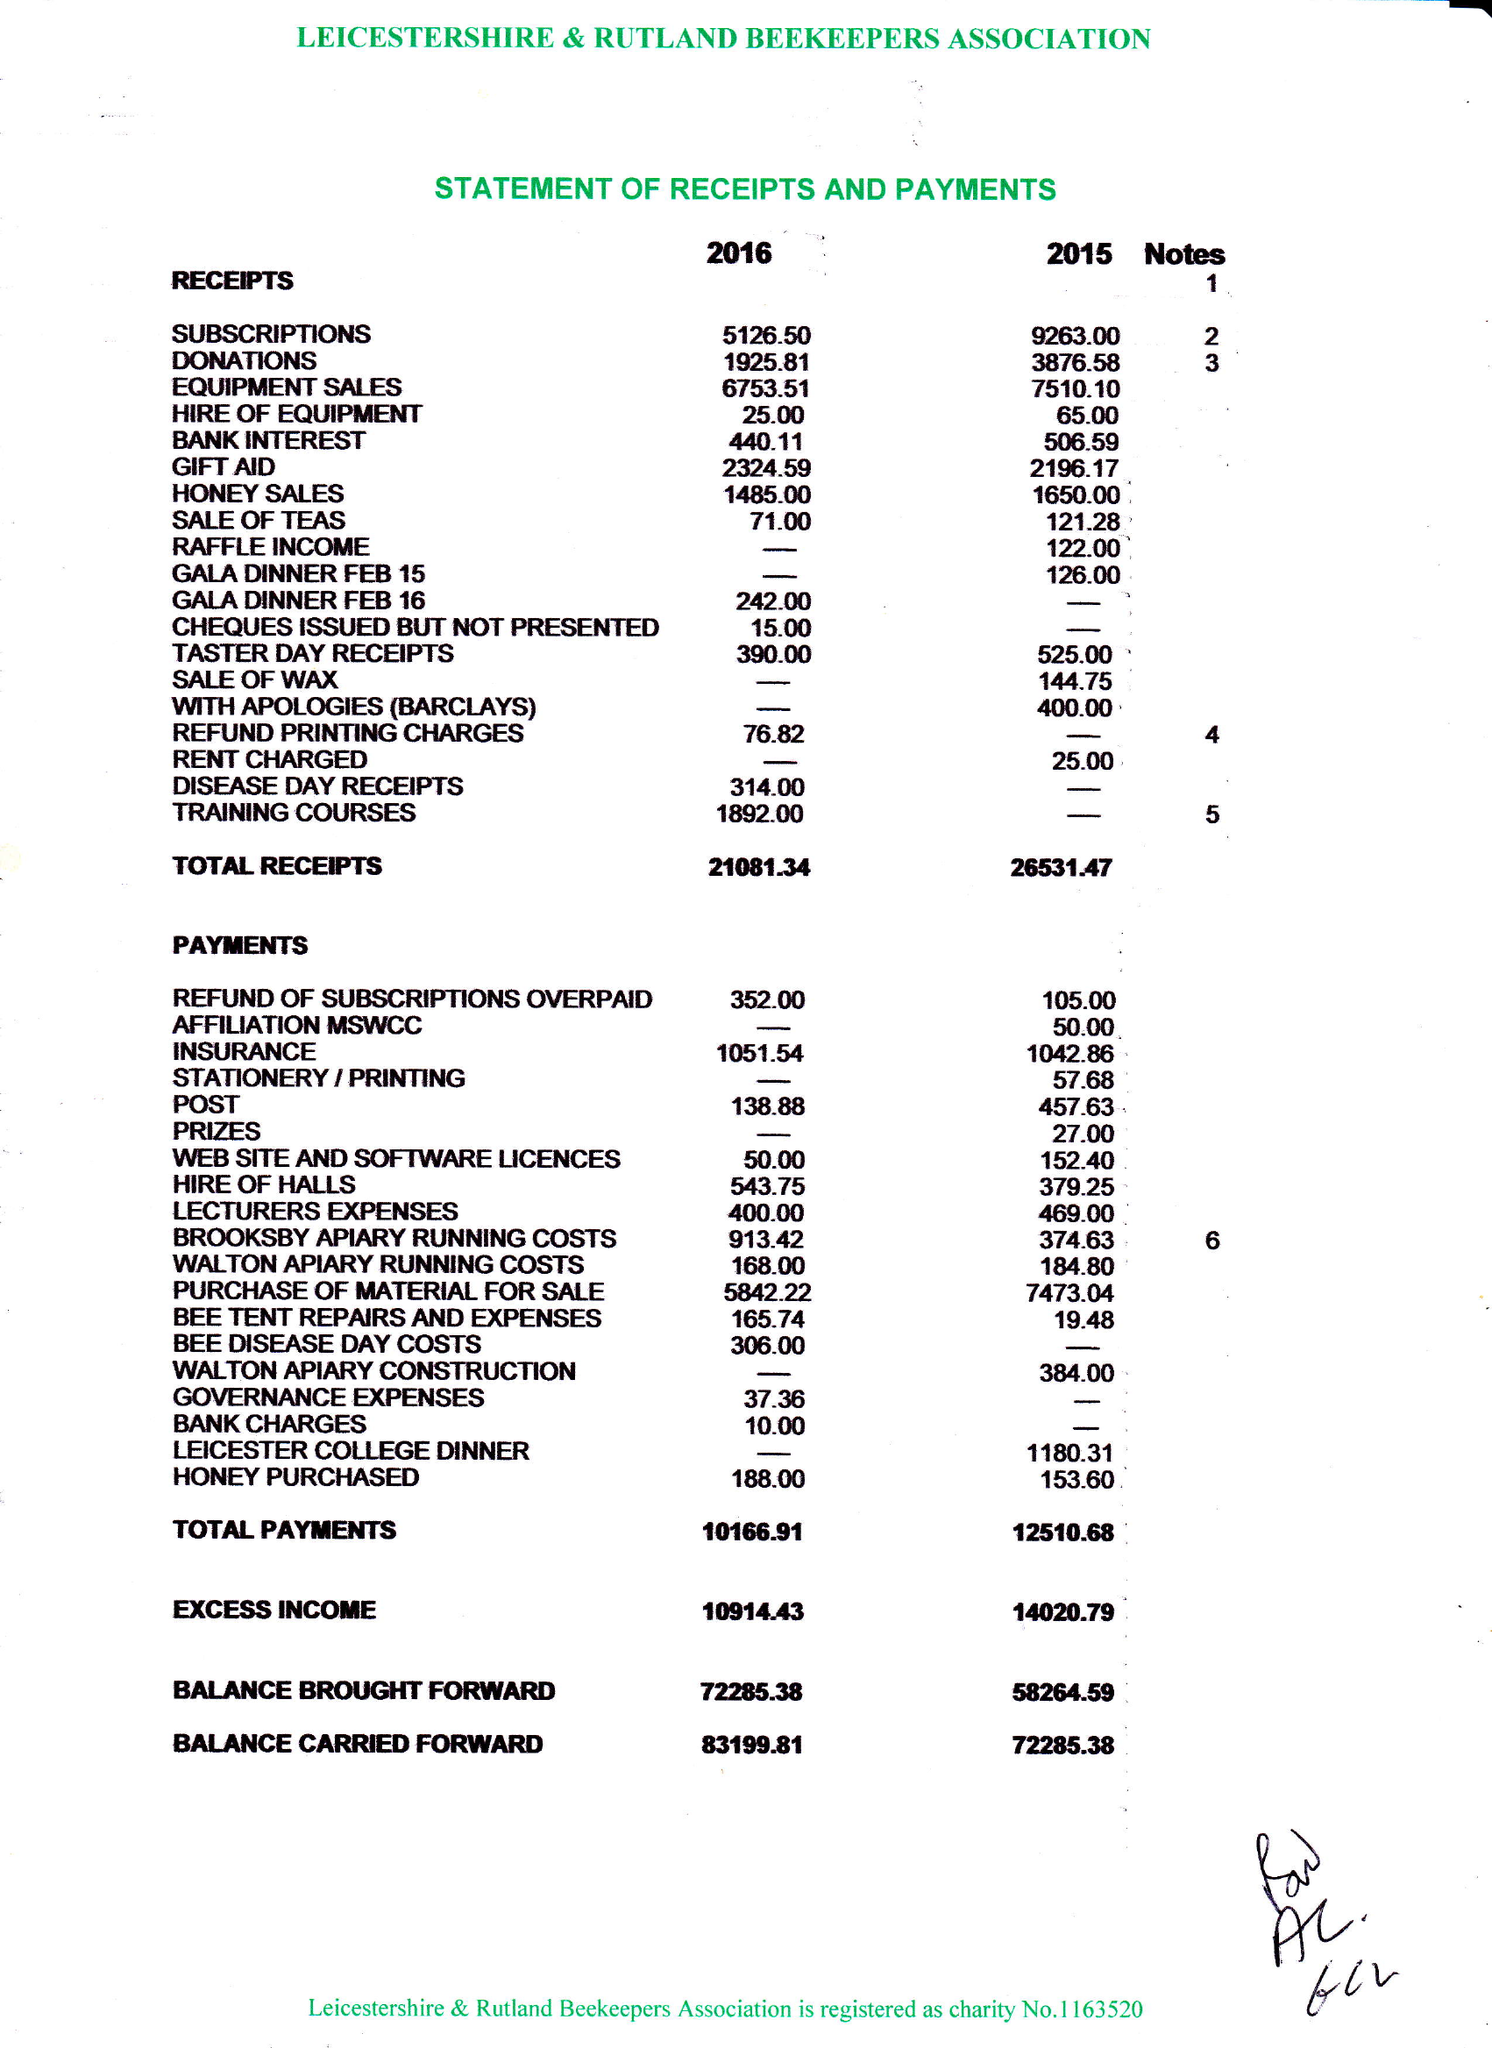What is the value for the address__street_line?
Answer the question using a single word or phrase. PARK LANE 